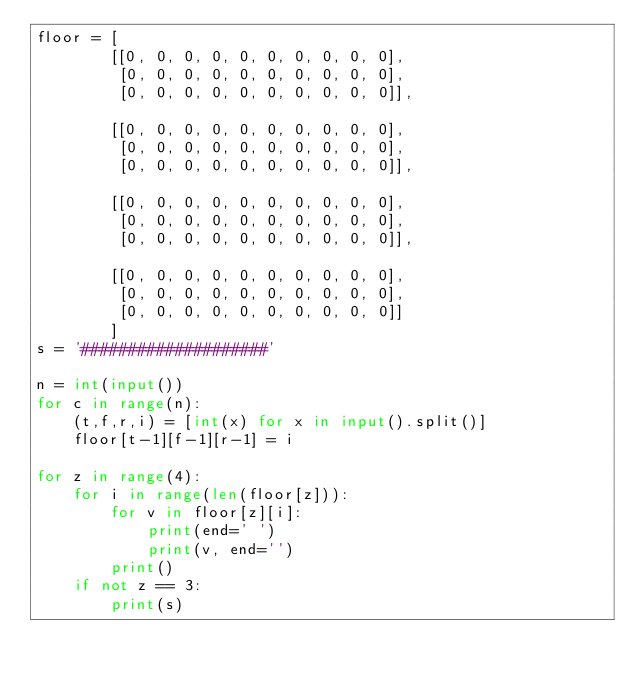Convert code to text. <code><loc_0><loc_0><loc_500><loc_500><_Python_>floor = [
        [[0, 0, 0, 0, 0, 0, 0, 0, 0, 0],
         [0, 0, 0, 0, 0, 0, 0, 0, 0, 0],
         [0, 0, 0, 0, 0, 0, 0, 0, 0, 0]],

        [[0, 0, 0, 0, 0, 0, 0, 0, 0, 0],
         [0, 0, 0, 0, 0, 0, 0, 0, 0, 0],
         [0, 0, 0, 0, 0, 0, 0, 0, 0, 0]],

        [[0, 0, 0, 0, 0, 0, 0, 0, 0, 0],
         [0, 0, 0, 0, 0, 0, 0, 0, 0, 0],
         [0, 0, 0, 0, 0, 0, 0, 0, 0, 0]],

        [[0, 0, 0, 0, 0, 0, 0, 0, 0, 0],
         [0, 0, 0, 0, 0, 0, 0, 0, 0, 0],
         [0, 0, 0, 0, 0, 0, 0, 0, 0, 0]]
        ]
s = '####################'

n = int(input())
for c in range(n):
    (t,f,r,i) = [int(x) for x in input().split()]
    floor[t-1][f-1][r-1] = i

for z in range(4):
    for i in range(len(floor[z])):
        for v in floor[z][i]:
            print(end=' ')
            print(v, end='')
        print()
    if not z == 3:
        print(s)</code> 